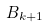<formula> <loc_0><loc_0><loc_500><loc_500>B _ { k + 1 }</formula> 